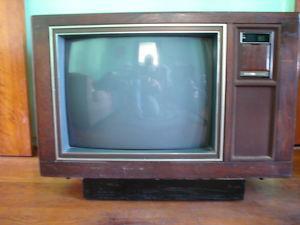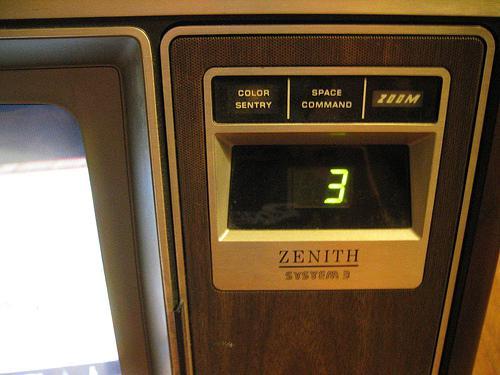The first image is the image on the left, the second image is the image on the right. Analyze the images presented: Is the assertion "At least one object sit atop the television in the image on the left." valid? Answer yes or no. No. 